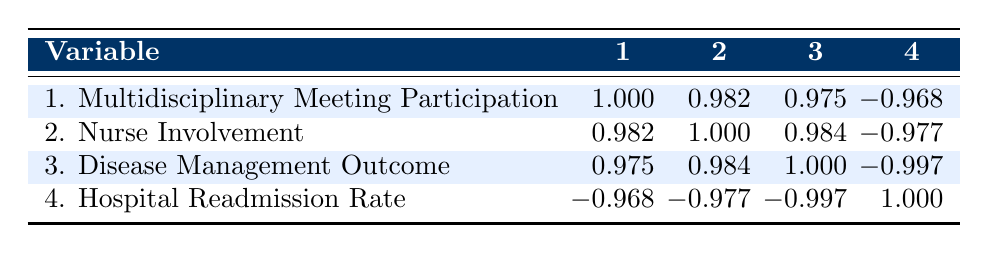What is the correlation between Multidisciplinary Meeting Participation and Nurse Involvement? The table shows that the correlation value is 0.982, which indicates a very strong positive relationship between these two variables.
Answer: 0.982 What is the correlation coefficient between Disease Management Outcome and Hospital Readmission Rate? The table shows that the correlation coefficient is -0.997, indicating a very strong negative relationship; as the disease management outcome improves, the hospital readmission rate tends to decrease.
Answer: -0.997 Is the correlation between Nurse Involvement and Disease Management Outcomes positive? Yes, the correlation value between Nurse Involvement and Disease Management Outcomes is 0.984, indicating a positive relationship.
Answer: Yes What is the highest correlation coefficient found in the table? The highest correlation coefficient is 1.000, which indicates perfect correlation; however, that would typically not show up in a meaningful relationship in this context as it suggests identical behavior.
Answer: 1.000 What is the combined average of the Multidisciplinary Meeting Participation and Nurse Involvement scores across all patients? The scores are 8, 7, 9, 6, 8, 5, 9, and 4 for participation (total 56) and 9, 8, 10, 7, 9, 6, 9, and 5 for involvement (total 63). The averages are (56/8) = 7 and (63/8) = 7.875. Thus, the combined average is (7 + 7.875)/2 = 7.4375.
Answer: 7.4375 If a patient has a Multidisciplinary Meeting Participation score of 5, what can be inferred about the Hospital Readmission Rate based on the correlation? Given the negative correlation of -0.968 between Multidisciplinary Meeting Participation and Hospital Readmission Rate, if a patient has a low participation score like 5, it can be inferred that the Hospital Readmission Rate is likely to be high, but the exact number cannot be determined without further data.
Answer: Likely high 